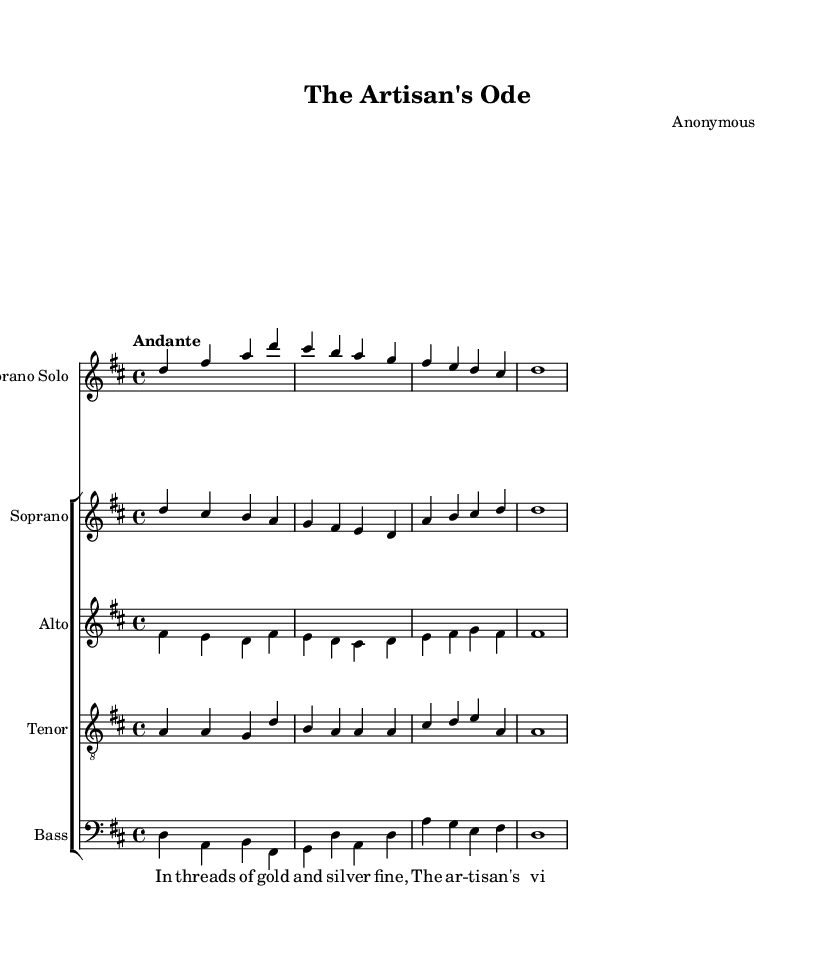What is the key signature of this music? The key signature is D major, which has two sharps (F# and C#). This is confirmed by looking for the sharps at the beginning of the staff.
Answer: D major What is the time signature of this piece? The time signature is 4/4, which indicates that there are four beats in each measure and the quarter note receives one beat. This is shown at the beginning of the score where the time signature is notated.
Answer: 4/4 What is the tempo marking of this work? The tempo marking is "Andante," which suggests a moderate walking pace. This is indicated at the beginning of the score right after the key signature.
Answer: Andante How many vocal parts are featured in this composition? There are five vocal parts indicated in the score: Soprano Solo, Soprano, Alto, Tenor, and Bass. These can be counted by looking at the number of different staves listed in the score section.
Answer: Five What form of music does this piece represent? This piece represents an oratorio, which is a large-scale musical work for orchestra and voices, typically based on a religious theme. The composition's title along with the context of the lyrics and structure suggests this form.
Answer: Oratorio In which century was this piece likely composed? This piece was likely composed in the 17th or 18th century, which is known as the Baroque period. This can be inferred from the style and characteristics typical of Baroque music, such as ornamentation and the use of contrasting textures.
Answer: 17th or 18th century What is the predominant vocal range in the soprano choir part? The predominant vocal range in the soprano choir part is from D to D, suggesting it is written for higher voices as typically found in soprano sections. This can be determined by analyzing the pitches used in the soprano choir stanza.
Answer: Soprano 